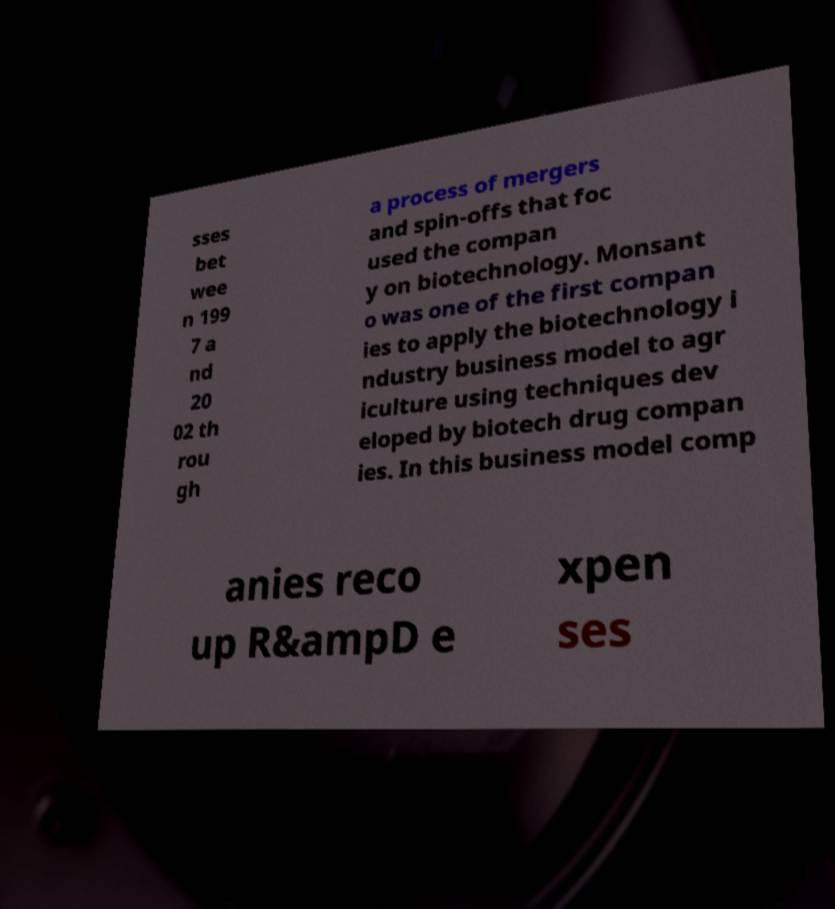Please read and relay the text visible in this image. What does it say? sses bet wee n 199 7 a nd 20 02 th rou gh a process of mergers and spin-offs that foc used the compan y on biotechnology. Monsant o was one of the first compan ies to apply the biotechnology i ndustry business model to agr iculture using techniques dev eloped by biotech drug compan ies. In this business model comp anies reco up R&ampD e xpen ses 